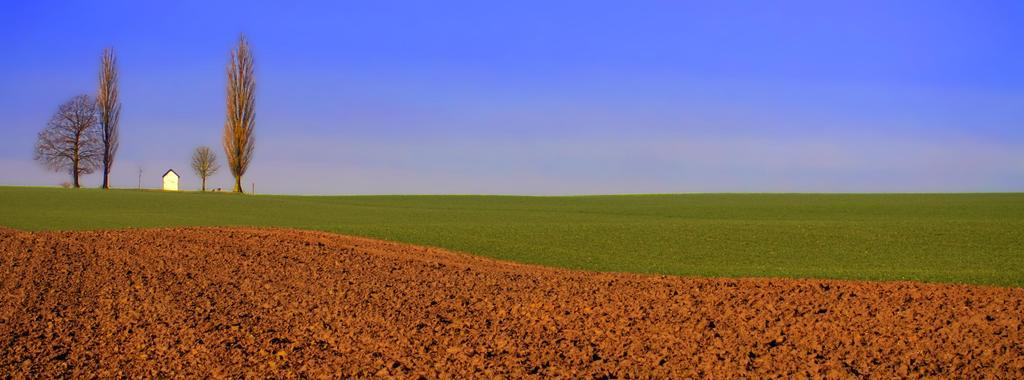What type of vegetation can be seen in the image? There is grass in the image. What color is the soil in the image? There is red soil in the image. What other natural elements are present in the image? There are trees in the image. What type of structure can be seen in the image? There is a house in the image. What is the color of the sky in the image? The sky is blue in the image. What team is playing in the image? There is no team playing in the image; it features natural elements and a house. How does the rod affect the grass in the image? There is no rod present in the image, so it cannot affect the grass. 